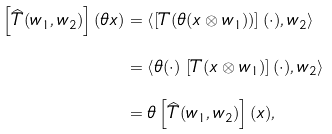Convert formula to latex. <formula><loc_0><loc_0><loc_500><loc_500>\left [ \widehat { T } ( w _ { 1 } , w _ { 2 } ) \right ] ( \theta x ) & = \left \langle \left [ T ( \theta ( x \otimes w _ { 1 } ) ) \right ] ( \cdot ) , w _ { 2 } \right \rangle \\ & = \left \langle \theta ( \cdot ) \, \left [ T ( x \otimes w _ { 1 } ) \right ] ( \cdot ) , w _ { 2 } \right \rangle \\ & = \theta \left [ \widehat { T } ( w _ { 1 } , w _ { 2 } ) \right ] ( x ) ,</formula> 